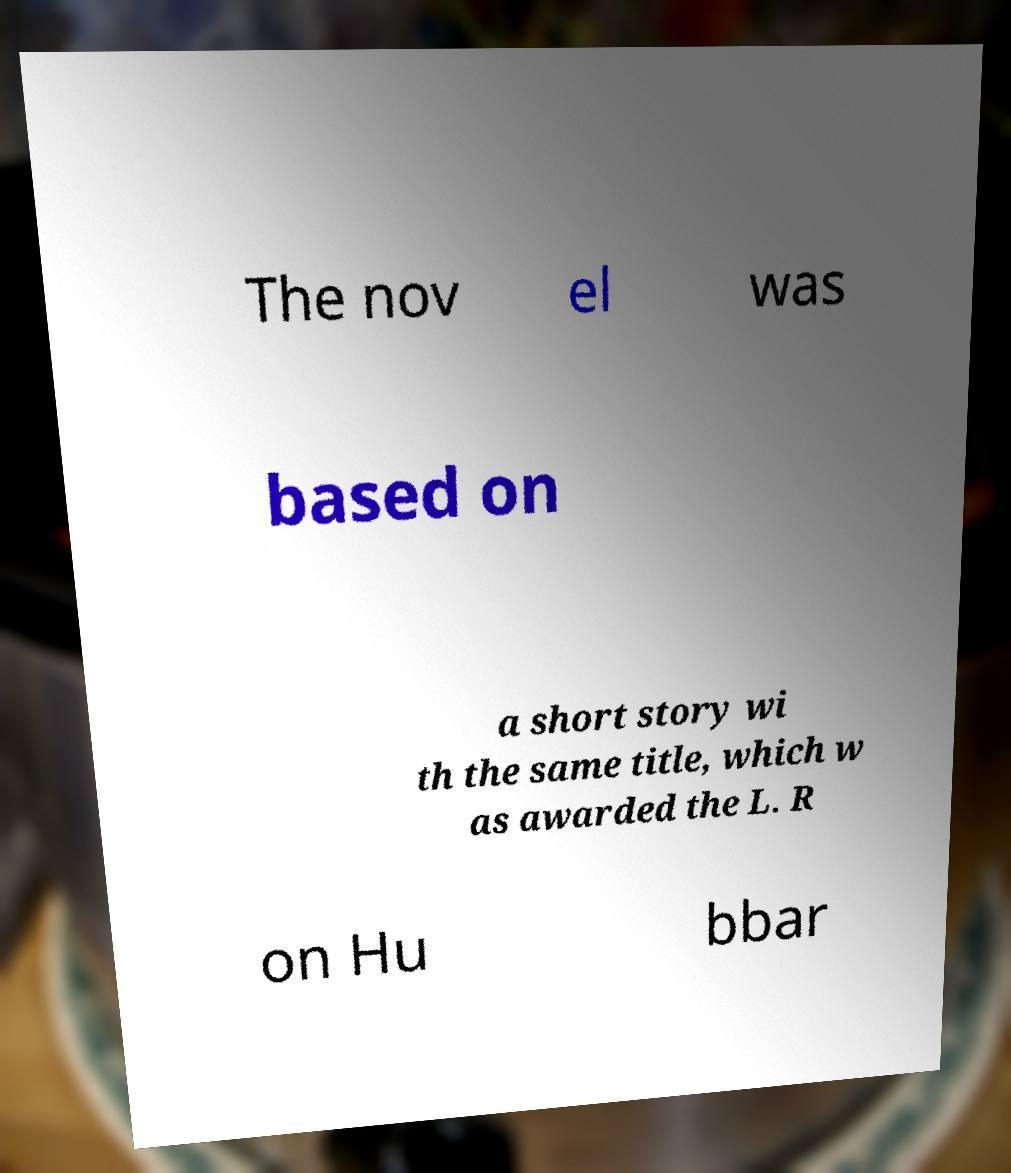Please identify and transcribe the text found in this image. The nov el was based on a short story wi th the same title, which w as awarded the L. R on Hu bbar 